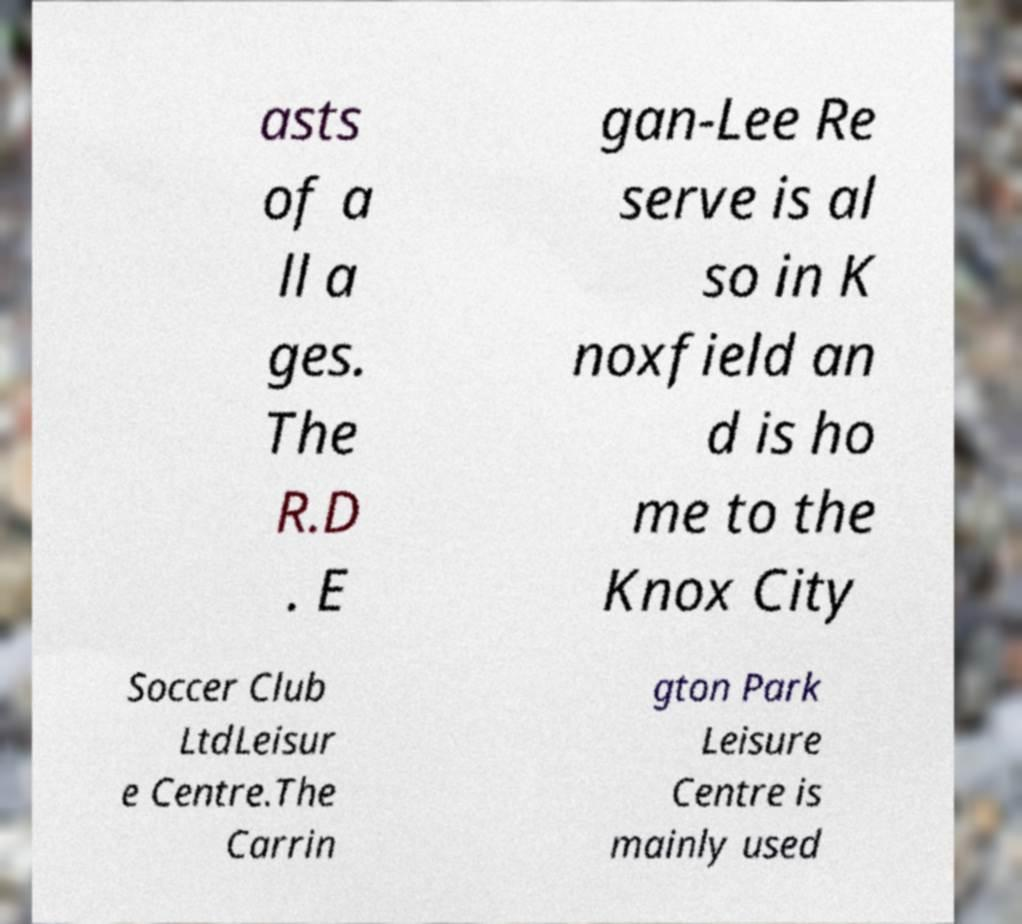Could you extract and type out the text from this image? asts of a ll a ges. The R.D . E gan-Lee Re serve is al so in K noxfield an d is ho me to the Knox City Soccer Club LtdLeisur e Centre.The Carrin gton Park Leisure Centre is mainly used 